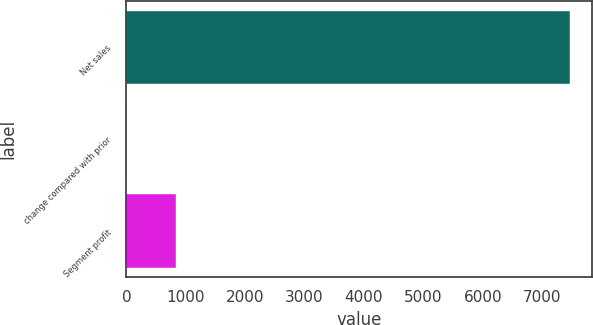<chart> <loc_0><loc_0><loc_500><loc_500><bar_chart><fcel>Net sales<fcel>change compared with prior<fcel>Segment profit<nl><fcel>7464<fcel>7<fcel>843<nl></chart> 